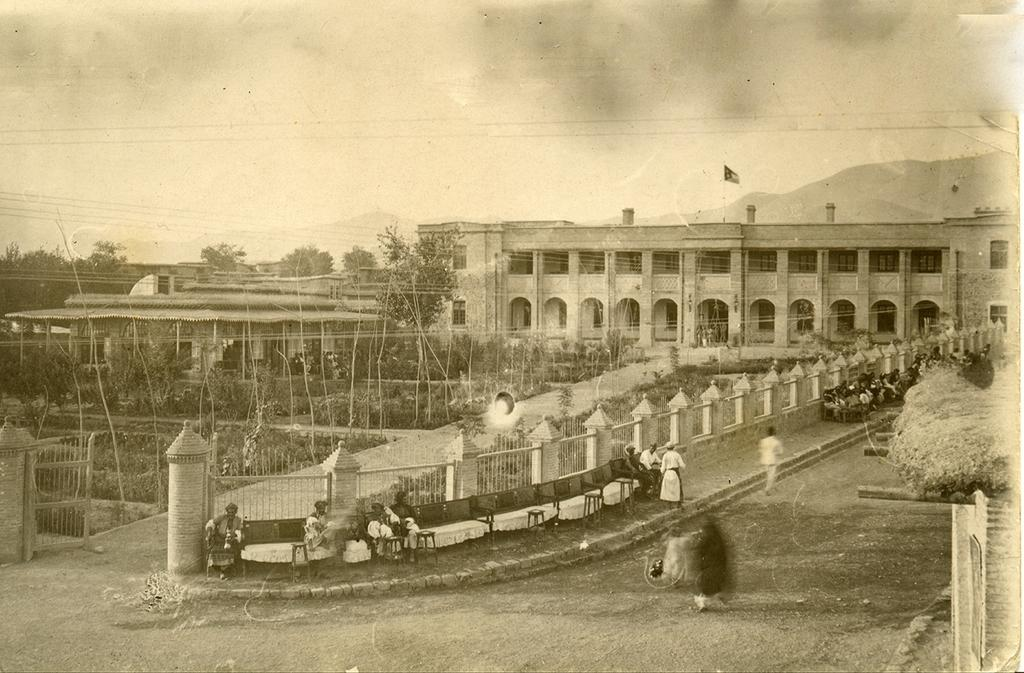How many people are present in the image? There are persons standing in the image. What type of structure can be seen in the image? There is a building in the image. What type of vegetation is present in the image? There are plants and trees in the image. What type of pathway is visible in the image? There is a road in the image. What is visible in the background of the image? The sky is visible in the background of the image. What type of soda is being advertised on the calendar in the image? There is no soda or calendar present in the image. What example of a fruit can be seen hanging from the trees in the image? There is no fruit visible on the trees in the image. 